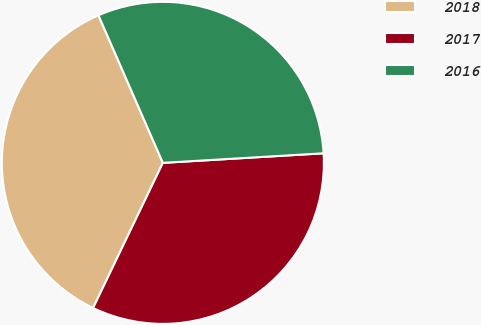Convert chart. <chart><loc_0><loc_0><loc_500><loc_500><pie_chart><fcel>2018<fcel>2017<fcel>2016<nl><fcel>36.32%<fcel>33.08%<fcel>30.6%<nl></chart> 